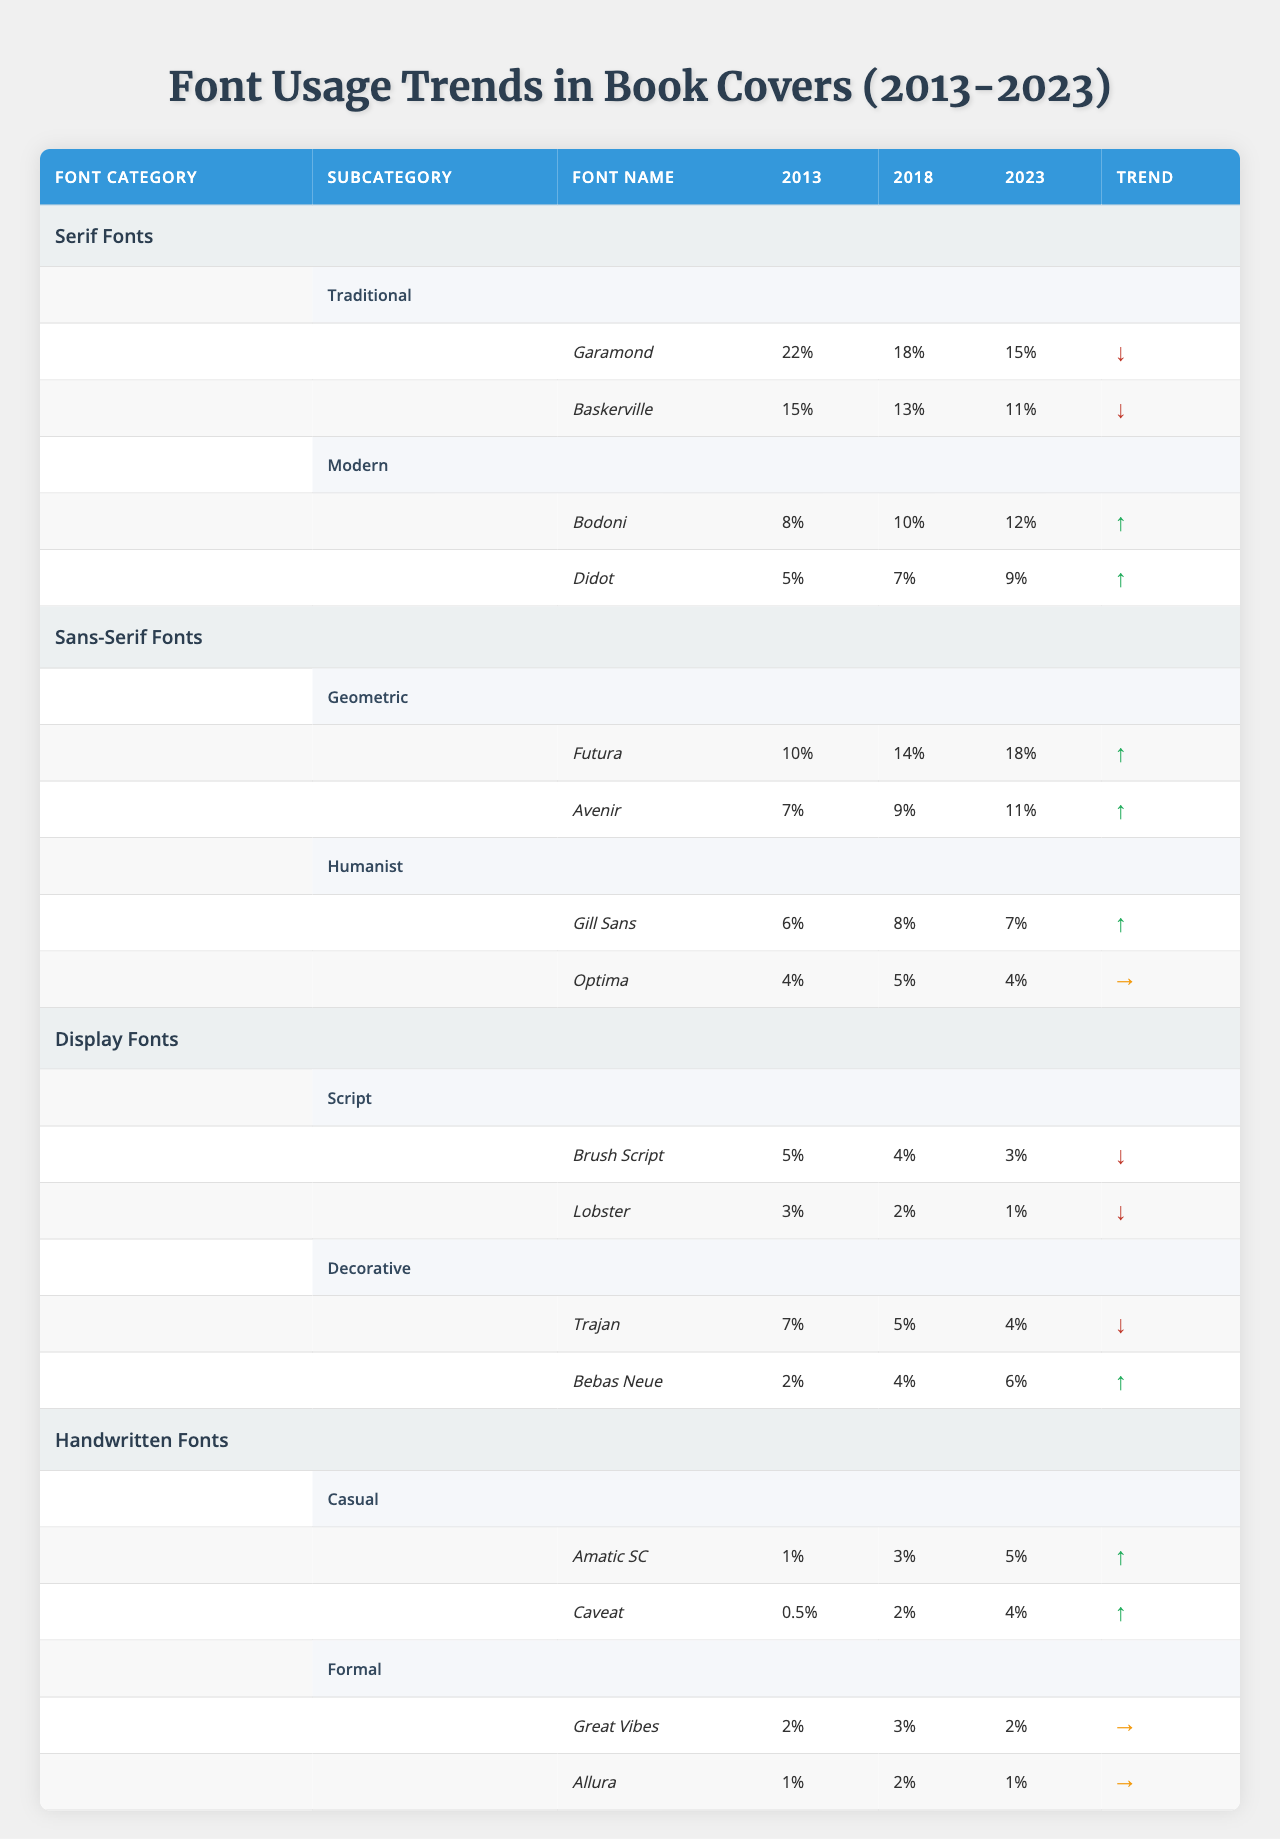What was the percentage usage of Garamond in book covers in 2023? Referring to the table, Garamond's percentage in 2023 is listed as 15%.
Answer: 15% Which font saw an increase in usage from 2013 to 2023 among the geometric sans-serif fonts? In the geometric category, Futura increased from 10% in 2013 to 18% in 2023, while Avenir increased from 7% to 11%. Both showed an increase, but Futura's growth was more significant.
Answer: Futura What is the trend for Baskerville from 2013 to 2023? Looking at Baskerville's percentages, they decreased from 15% in 2013 to 11% in 2023. Therefore, the trend is downward.
Answer: Down Which display font had the highest usage in 2013? By reviewing the percentages in the table, Trajan had the highest usage at 7% in 2013 among display fonts.
Answer: Trajan What is the average percentage usage of Casual handwritten fonts in 2023? The percentages for the Casual fonts Amatic SC (5%) and Caveat (4%) are summed: 5% + 4% = 9%; then divided by 2 (because there are 2 fonts), resulting in an average of 4.5%.
Answer: 4.5% Did Optima see an increase or decrease in usage from 2013 to 2023? For Optima, the usage was 4% in 2013 and remained the same at 4% in 2023. Therefore, there was no change.
Answer: No change What percentage did Bebas Neue increase to by 2023, and what was its change from 2013? Bebas Neue increased to 6% in 2023, up from 2% in 2013. The change is 6% - 2% = 4%, indicating an increase.
Answer: 4% Which serif modern font had the highest percentage usage in 2023? Among modern serif fonts, Didot had a percentage of 9% in 2023, which is higher than Bodoni's 12%.
Answer: Bodoni Was the overall trend for traditional serif fonts positive or negative from 2013 to 2023? The traditional serif fonts saw a decline (Garamond from 22% to 15% and Baskerville from 15% to 11%), indicating a negative trend overall.
Answer: Negative Which font category experienced the most significant increase in percentage over the decade? Futura saw an increase from 10% in 2013 to 18% in 2023, representing an 8% increase, which is the most significant among all categories.
Answer: Geometric Sans-Serif Fonts 